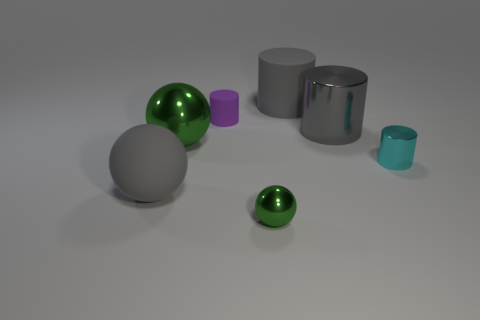What number of other objects are the same color as the big shiny cylinder?
Your response must be concise. 2. Are there any metallic objects of the same color as the rubber sphere?
Provide a succinct answer. Yes. Do the tiny ball and the big metallic object that is on the left side of the gray shiny cylinder have the same color?
Give a very brief answer. Yes. What is the material of the purple thing to the right of the gray rubber object in front of the cyan metal cylinder?
Make the answer very short. Rubber. There is a large metallic object that is the same color as the rubber sphere; what is its shape?
Your response must be concise. Cylinder. Does the small sphere have the same color as the large metal sphere?
Your answer should be compact. Yes. There is a rubber thing that is behind the small matte object; does it have the same color as the big metallic cylinder?
Make the answer very short. Yes. Is the gray shiny object the same size as the gray matte ball?
Make the answer very short. Yes. What is the material of the tiny purple object that is the same shape as the cyan object?
Provide a short and direct response. Rubber. Is there anything else that has the same material as the tiny ball?
Your response must be concise. Yes. 